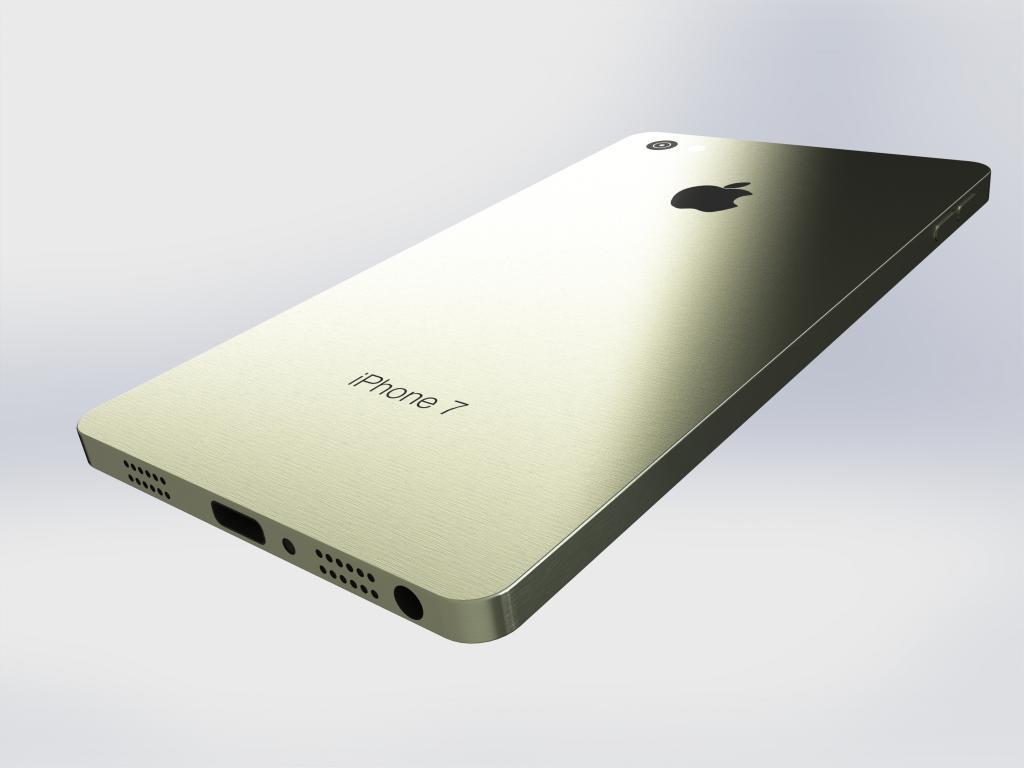<image>
Provide a brief description of the given image. A iPhone7 floating with a blurred background reflecting light. 